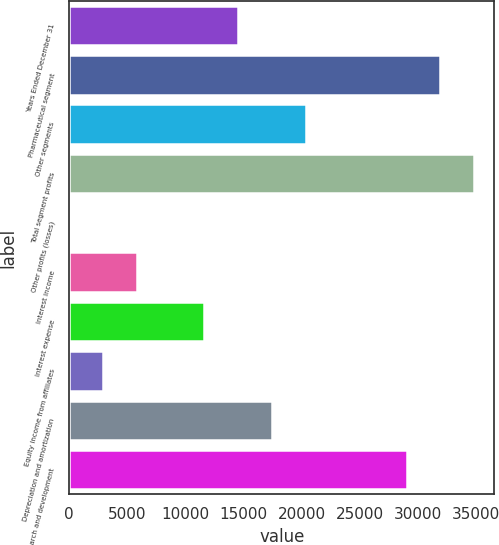Convert chart to OTSL. <chart><loc_0><loc_0><loc_500><loc_500><bar_chart><fcel>Years Ended December 31<fcel>Pharmaceutical segment<fcel>Other segments<fcel>Total segment profits<fcel>Other profits (losses)<fcel>Interest income<fcel>Interest expense<fcel>Equity income from affiliates<fcel>Depreciation and amortization<fcel>Research and development<nl><fcel>14520.5<fcel>31913.9<fcel>20318.3<fcel>34812.8<fcel>26<fcel>5823.8<fcel>11621.6<fcel>2924.9<fcel>17419.4<fcel>29015<nl></chart> 